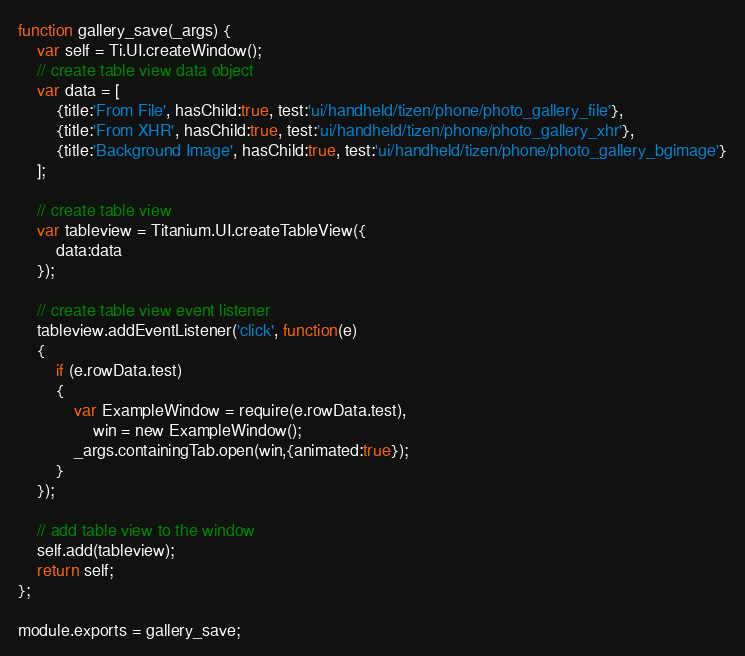<code> <loc_0><loc_0><loc_500><loc_500><_JavaScript_>function gallery_save(_args) {
	var self = Ti.UI.createWindow();
	// create table view data object
	var data = [
	    {title:'From File', hasChild:true, test:'ui/handheld/tizen/phone/photo_gallery_file'},
		{title:'From XHR', hasChild:true, test:'ui/handheld/tizen/phone/photo_gallery_xhr'},
		{title:'Background Image', hasChild:true, test:'ui/handheld/tizen/phone/photo_gallery_bgimage'}
	];
	
	// create table view
	var tableview = Titanium.UI.createTableView({
		data:data
	});
	
	// create table view event listener
	tableview.addEventListener('click', function(e)
	{
		if (e.rowData.test)
		{
			var ExampleWindow = require(e.rowData.test),
				win = new ExampleWindow();
			_args.containingTab.open(win,{animated:true});
		}
	});
	
	// add table view to the window
	self.add(tableview);
	return self;
};

module.exports = gallery_save;
</code> 